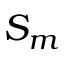Convert formula to latex. <formula><loc_0><loc_0><loc_500><loc_500>S _ { m }</formula> 